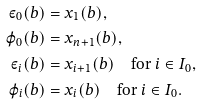<formula> <loc_0><loc_0><loc_500><loc_500>\varepsilon _ { 0 } ( b ) & = x _ { 1 } ( b ) , \\ \varphi _ { 0 } ( b ) & = x _ { n + 1 } ( b ) , \\ \varepsilon _ { i } ( b ) & = x _ { i + 1 } ( b ) \quad \text {for} \ i \in I _ { 0 } , \\ \varphi _ { i } ( b ) & = x _ { i } ( b ) \quad \text {for} \ i \in I _ { 0 } .</formula> 